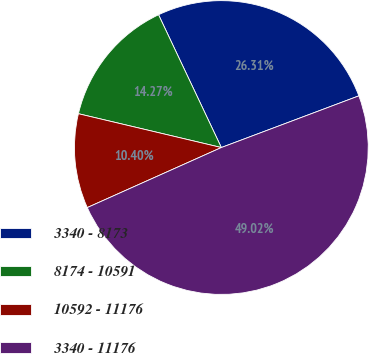Convert chart to OTSL. <chart><loc_0><loc_0><loc_500><loc_500><pie_chart><fcel>3340 - 8173<fcel>8174 - 10591<fcel>10592 - 11176<fcel>3340 - 11176<nl><fcel>26.31%<fcel>14.27%<fcel>10.4%<fcel>49.02%<nl></chart> 